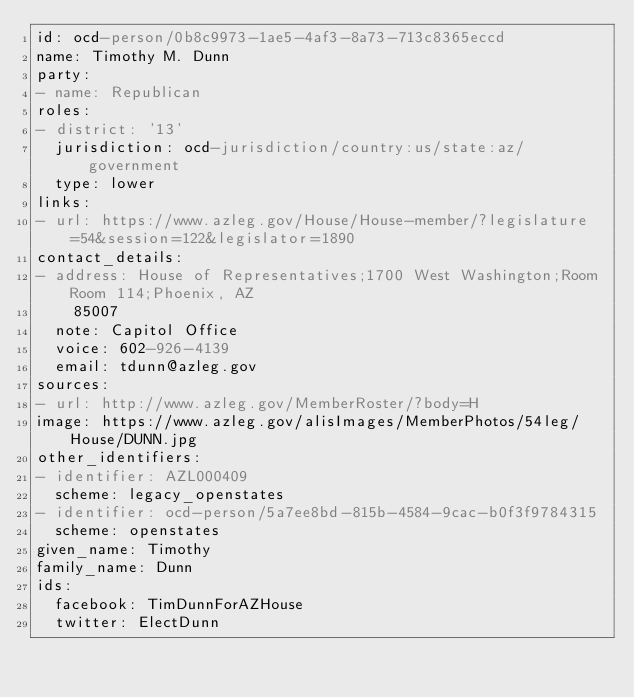<code> <loc_0><loc_0><loc_500><loc_500><_YAML_>id: ocd-person/0b8c9973-1ae5-4af3-8a73-713c8365eccd
name: Timothy M. Dunn
party:
- name: Republican
roles:
- district: '13'
  jurisdiction: ocd-jurisdiction/country:us/state:az/government
  type: lower
links:
- url: https://www.azleg.gov/House/House-member/?legislature=54&session=122&legislator=1890
contact_details:
- address: House of Representatives;1700 West Washington;Room Room 114;Phoenix, AZ
    85007
  note: Capitol Office
  voice: 602-926-4139
  email: tdunn@azleg.gov
sources:
- url: http://www.azleg.gov/MemberRoster/?body=H
image: https://www.azleg.gov/alisImages/MemberPhotos/54leg/House/DUNN.jpg
other_identifiers:
- identifier: AZL000409
  scheme: legacy_openstates
- identifier: ocd-person/5a7ee8bd-815b-4584-9cac-b0f3f9784315
  scheme: openstates
given_name: Timothy
family_name: Dunn
ids:
  facebook: TimDunnForAZHouse
  twitter: ElectDunn
</code> 